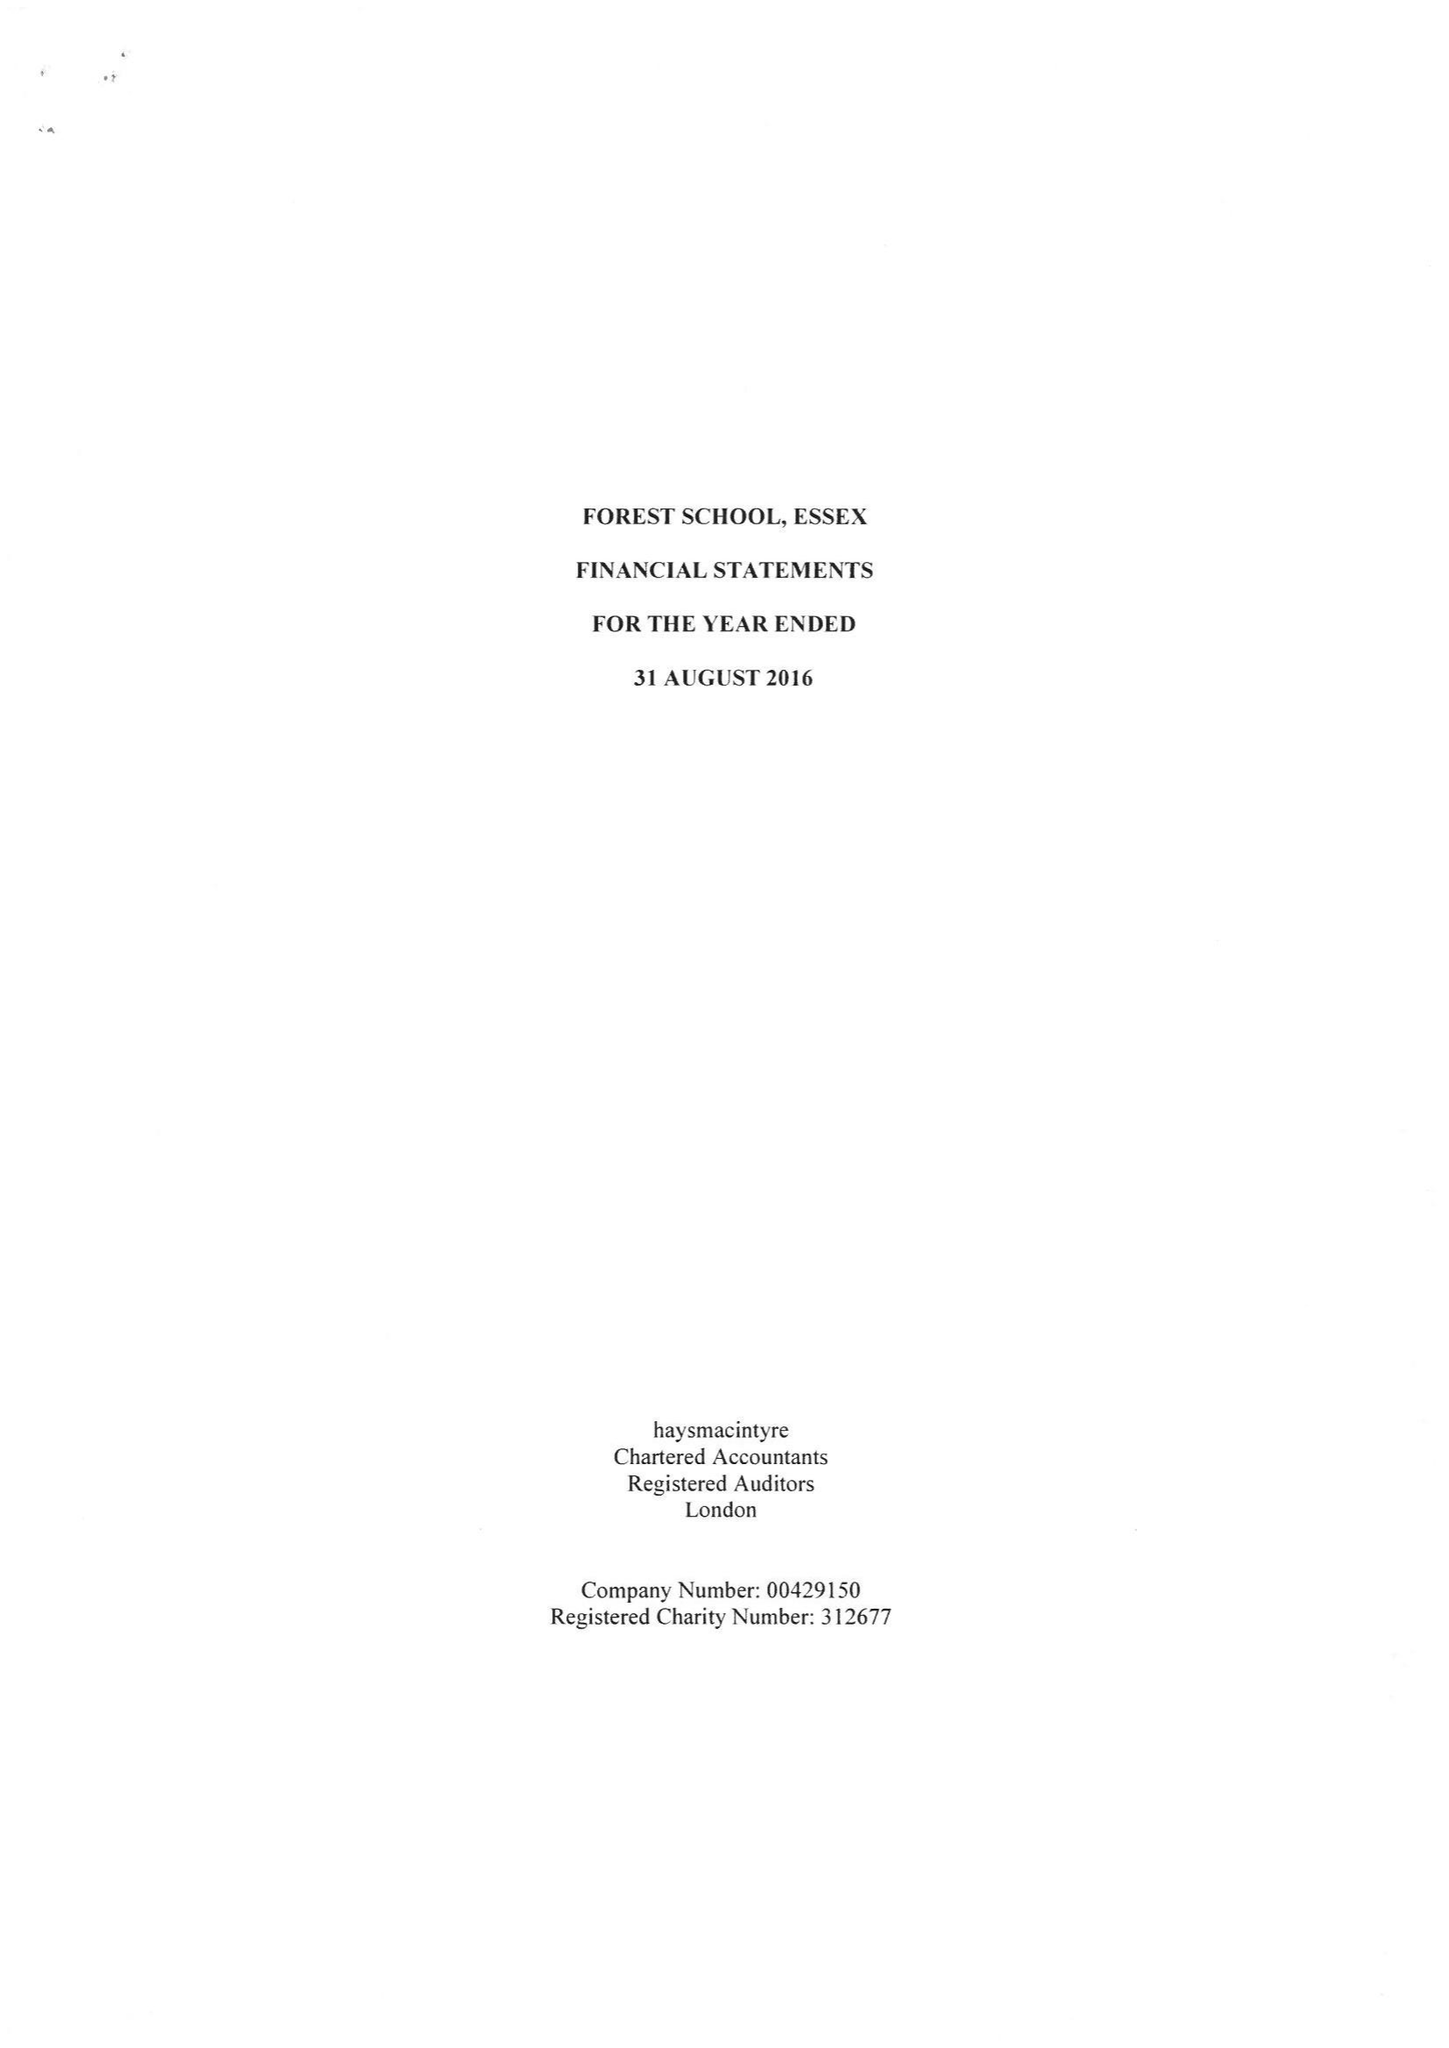What is the value for the address__postcode?
Answer the question using a single word or phrase. E17 3PY 